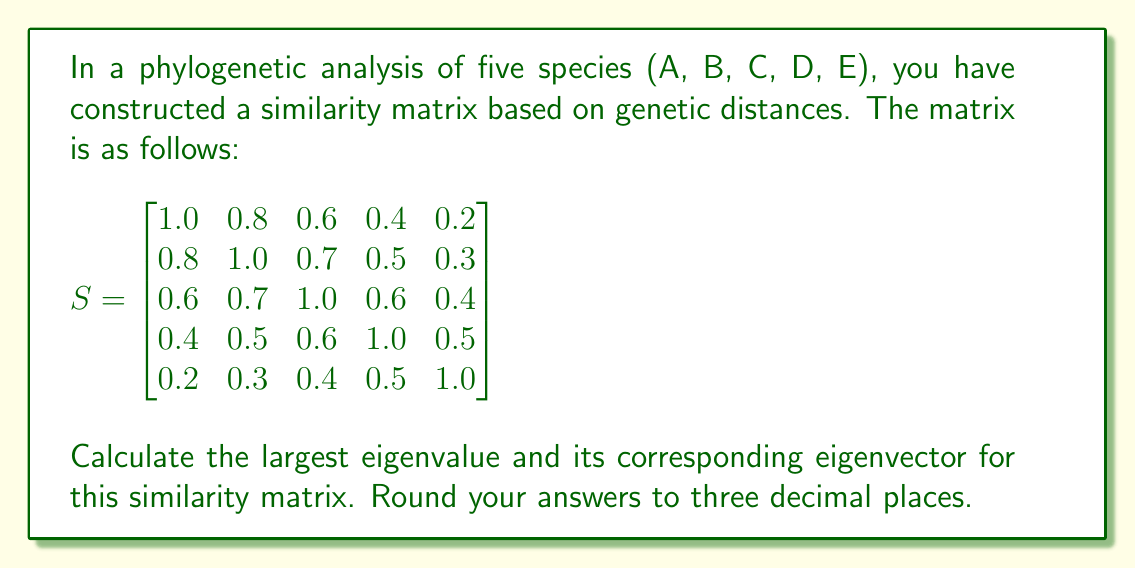Could you help me with this problem? To find the largest eigenvalue and its corresponding eigenvector, we'll use the power iteration method:

1) Start with a random vector $v_0 = [1, 1, 1, 1, 1]^T$.

2) Iterate:
   $v_{k+1} = Sv_k / ||Sv_k||$
   until convergence (when $v_{k+1}$ is very close to $v_k$).

3) The largest eigenvalue $\lambda$ is then approximated by the Rayleigh quotient:
   $\lambda \approx \frac{v_k^T S v_k}{v_k^T v_k}$

Let's perform a few iterations:

Iteration 1:
$$Sv_0 = [3.0, 3.3, 3.3, 3.0, 2.4]^T$$
$$v_1 = [0.577, 0.635, 0.635, 0.577, 0.462]^T$$

Iteration 2:
$$Sv_1 = [1.645, 1.730, 1.730, 1.645, 1.384]^T$$
$$v_2 = [0.580, 0.610, 0.610, 0.580, 0.488]^T$$

Iteration 3:
$$Sv_2 = [1.641, 1.719, 1.719, 1.641, 1.388]^T$$
$$v_3 = [0.580, 0.608, 0.608, 0.580, 0.491]^T$$

The process converges quickly. Using $v_3$ as our final eigenvector:

Largest eigenvalue:
$$\lambda \approx \frac{v_3^T S v_3}{v_3^T v_3} = 3.035$$

Normalized eigenvector:
$$v = [0.580, 0.608, 0.608, 0.580, 0.491]^T$$

Rounding to three decimal places:
Largest eigenvalue: 3.035
Eigenvector: [0.580, 0.608, 0.608, 0.580, 0.491]
Answer: Largest eigenvalue: 3.035
Eigenvector: [0.580, 0.608, 0.608, 0.580, 0.491] 